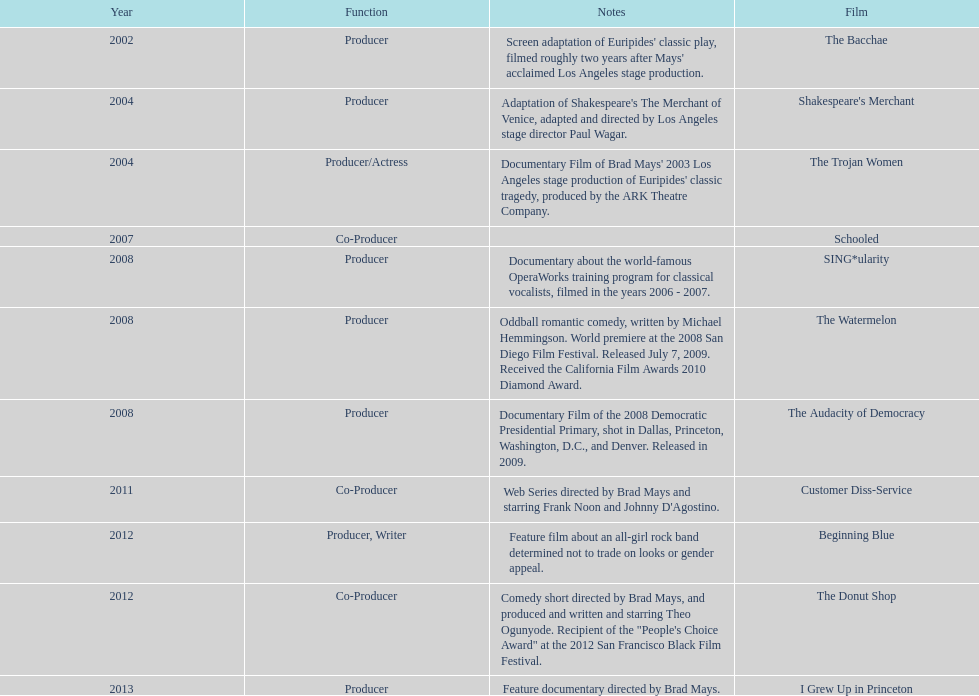How many years before was the film bacchae out before the watermelon? 6. 